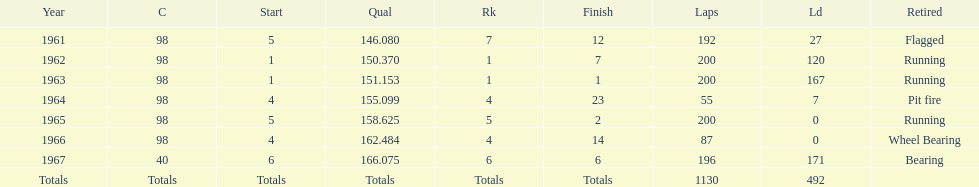How many total laps have been driven in the indy 500? 1130. 